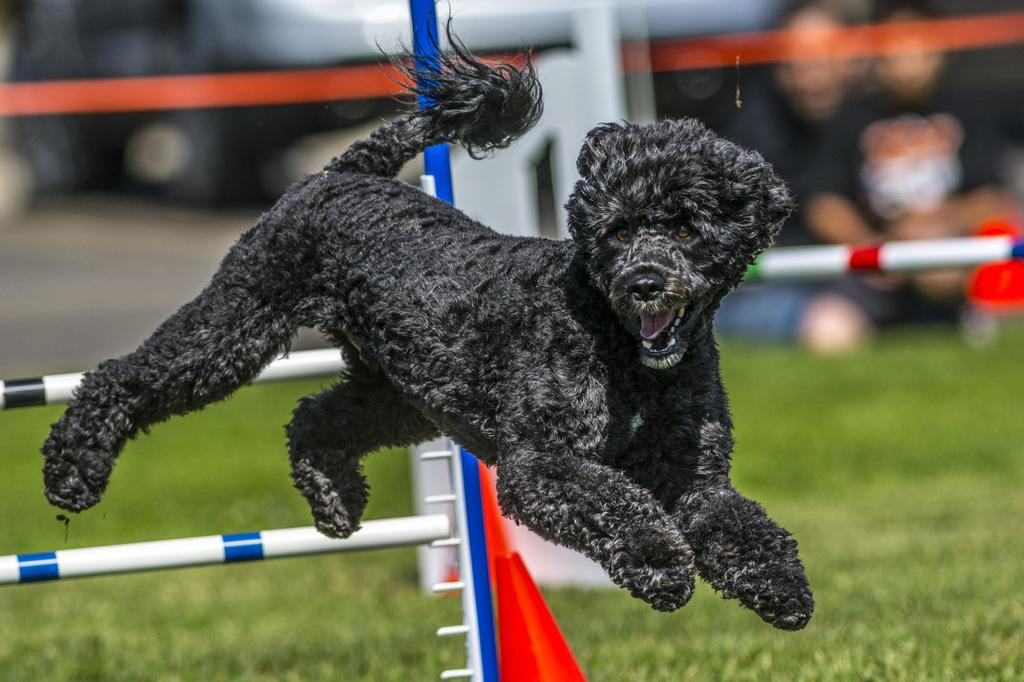What animal is present in the image? There is a dog in the image. How is the dog positioned in the image? The dog appears to be in the air. What can be seen in the background of the image? There are poles and grass visible in the image. What is the quality of the background in the image? The background of the image is blurry. Are there any other living beings present in the image? Yes, there are people in the background of the image. What type of goat can be seen in the image? There is no goat present in the image; it features a dog in the air. What is the cause of death for the dog in the image? There is no indication of death or any harm to the dog in the image. 